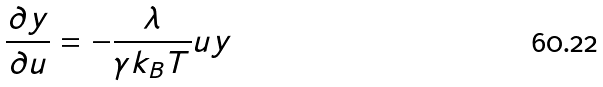Convert formula to latex. <formula><loc_0><loc_0><loc_500><loc_500>\frac { \partial y } { \partial u } = - \frac { \lambda } { \gamma k _ { B } T } u y</formula> 